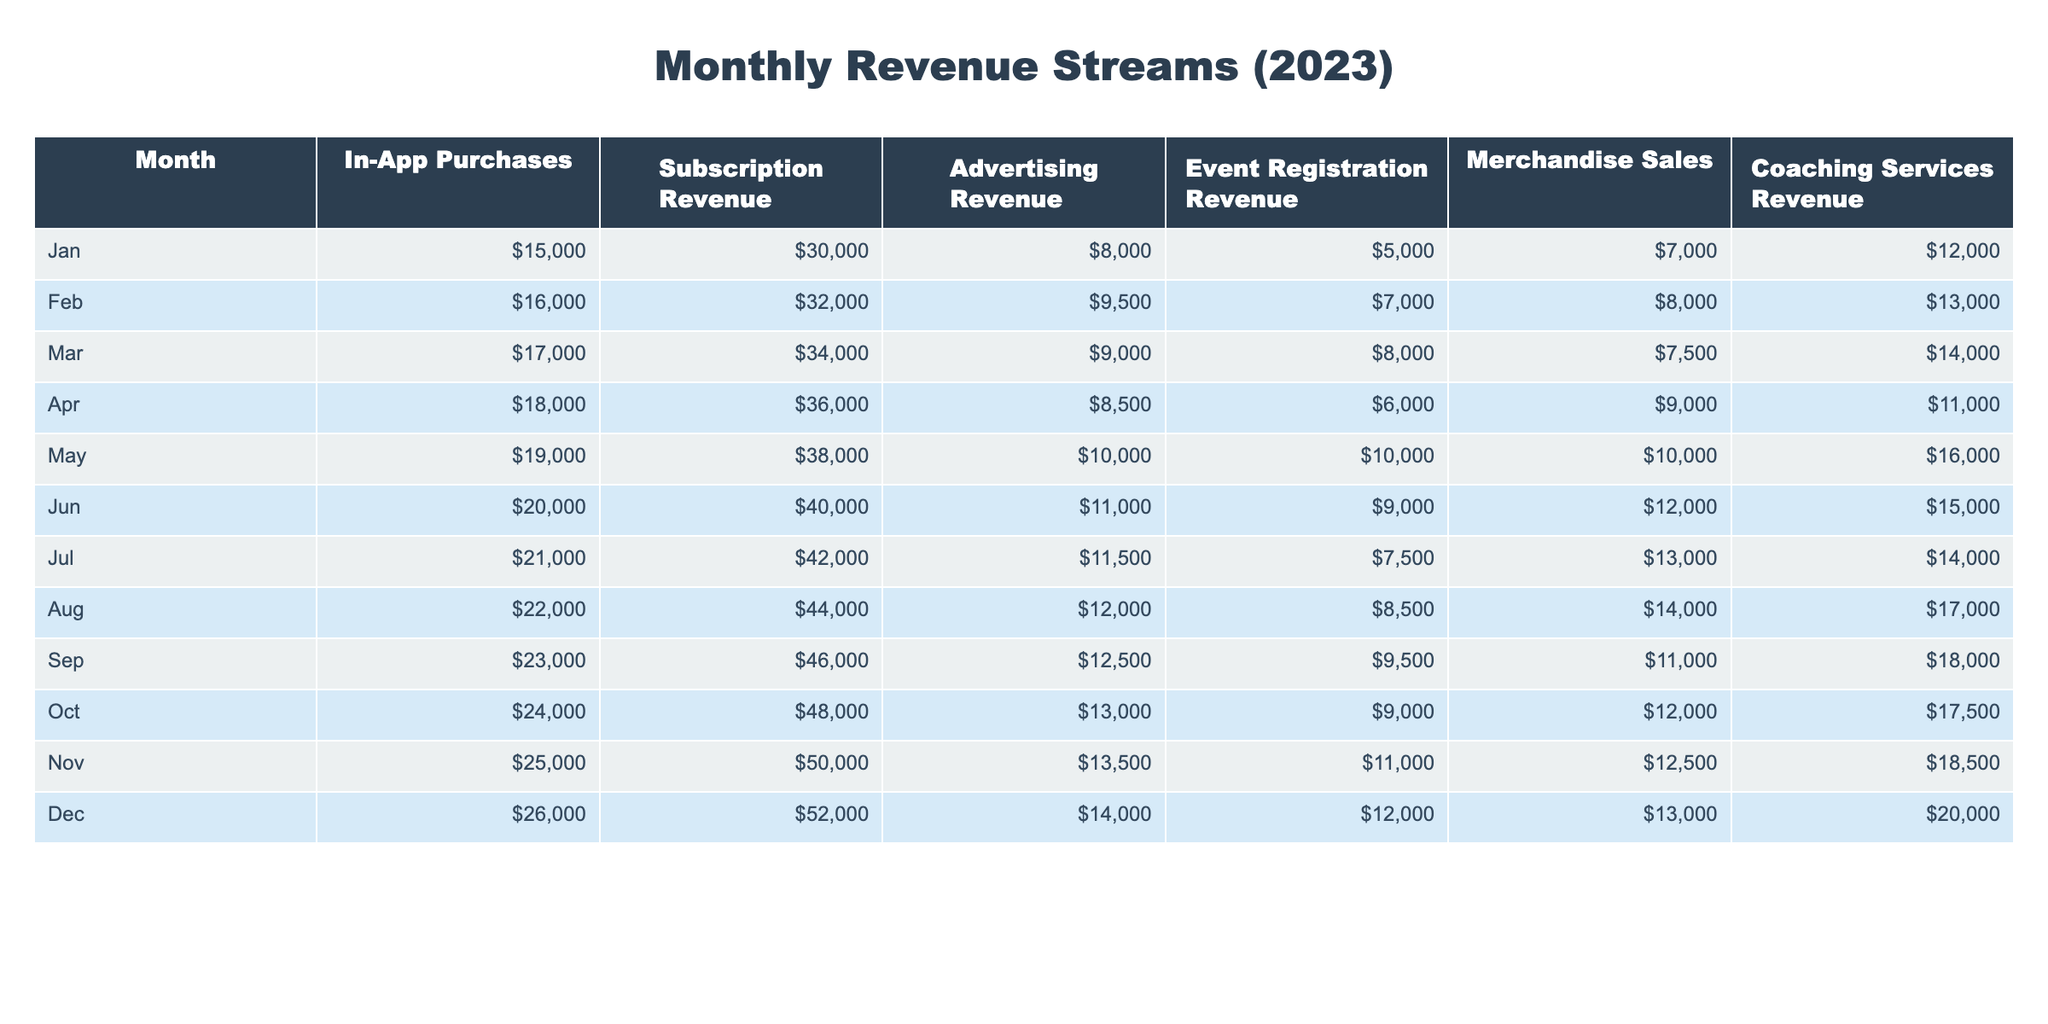What was the total revenue from in-app purchases in October? Referring to the table, the in-app purchases revenue for October is clearly listed as 24,000.
Answer: 24,000 Which month had the highest subscription revenue? Looking through the subscription revenue column, December shows the highest value of 52,000.
Answer: December What is the average advertising revenue for the first half of the year (January to June)? To find the average, sum the advertising revenues for January to June (8,000 + 9,500 + 9,000 + 8,500 + 10,000 + 11,000 = 56,000) and divide by 6, resulting in an average of 9,333.33.
Answer: 9,333.33 Was the merchandise sales revenue in April greater than that in June? The merchandise sales in April was 9,000 and in June it was 12,000. Since 9,000 is less than 12,000, the statement is false.
Answer: No What was the increase in coaching services revenue from January to November? The coaching services revenue in January is 12,000 and in November, it is 18,500. The increase is calculated as 18,500 - 12,000 = 6,500.
Answer: 6,500 Which month had the second highest event registration revenue, and what was that amount? By comparing the event registration revenue, December had the highest at 12,000 and November the second highest at 11,000.
Answer: November, 11,000 What is the total revenue from all sources in May? Adding the revenues for May: 19,000 (in-app) + 38,000 (subscription) + 10,000 (advertising) + 10,000 (event registration) + 10,000 (merchandise) + 16,000 (coaching) gives a total of 103,000.
Answer: 103,000 Did the in-app purchase revenue increase every month in 2023? Examining the in-app purchase revenue column, each month shows an increase from January (15,000) through December (26,000), confirming a consistent rise.
Answer: Yes What percentage of total revenue in August came from coaching services? First, calculate total revenue in August: 22,000 (in-app) + 44,000 (subscription) + 12,000 (advertising) + 8,500 (event registration) + 14,000 (merchandise) + 17,000 (coaching) = 117,500. Coaching services revenue is 17,000. Thus, the percentage is (17,000 / 117,500) * 100 ≈ 14.47%.
Answer: Approximately 14.47% What was the overall trend in subscription revenue from January to December? Observing the subscription revenue from January (30,000) to December (52,000), there is a clear and consistent upward trend each month, reflecting growth throughout the year.
Answer: Increasing trend 